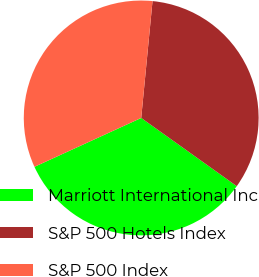<chart> <loc_0><loc_0><loc_500><loc_500><pie_chart><fcel>Marriott International Inc<fcel>S&P 500 Hotels Index<fcel>S&P 500 Index<nl><fcel>33.3%<fcel>33.33%<fcel>33.37%<nl></chart> 